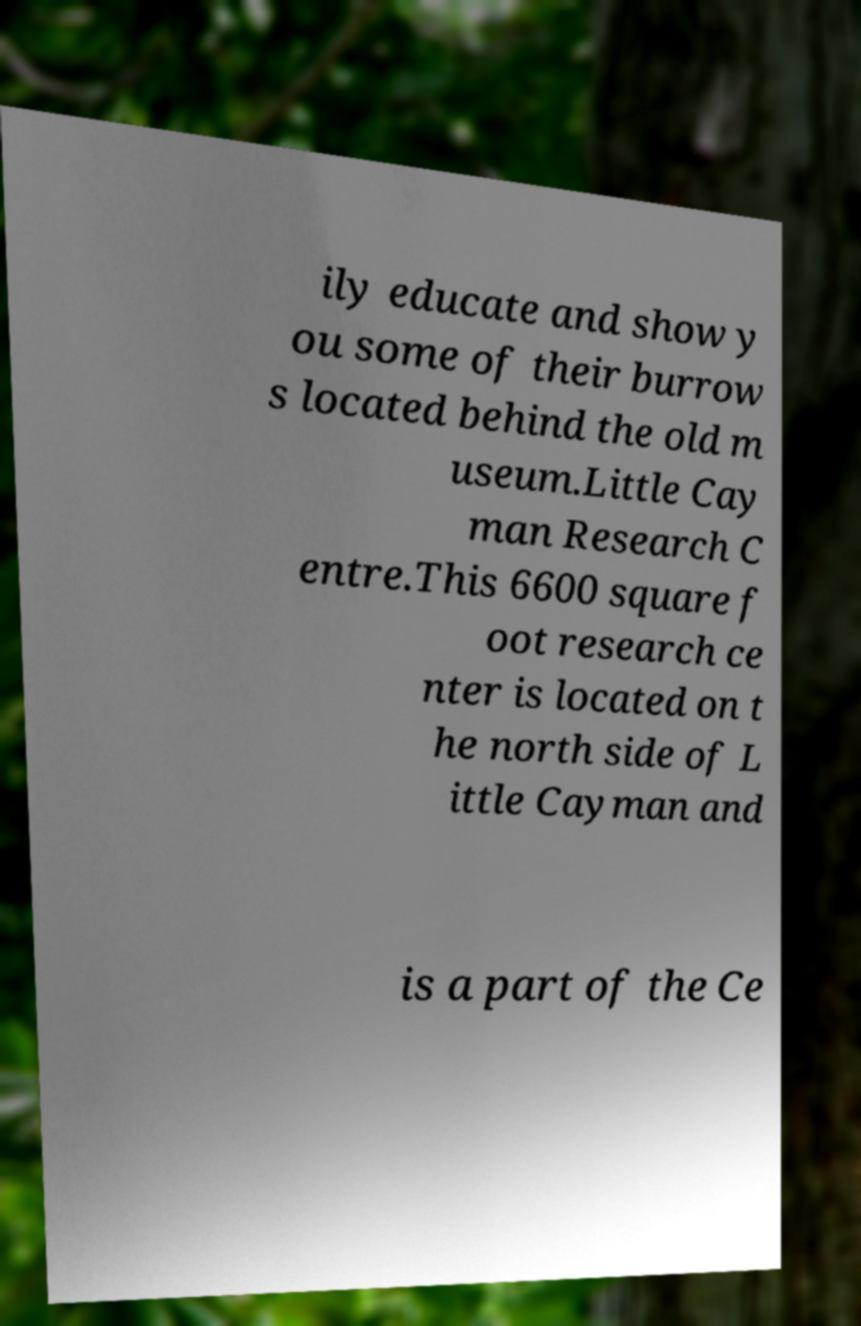What messages or text are displayed in this image? I need them in a readable, typed format. ily educate and show y ou some of their burrow s located behind the old m useum.Little Cay man Research C entre.This 6600 square f oot research ce nter is located on t he north side of L ittle Cayman and is a part of the Ce 